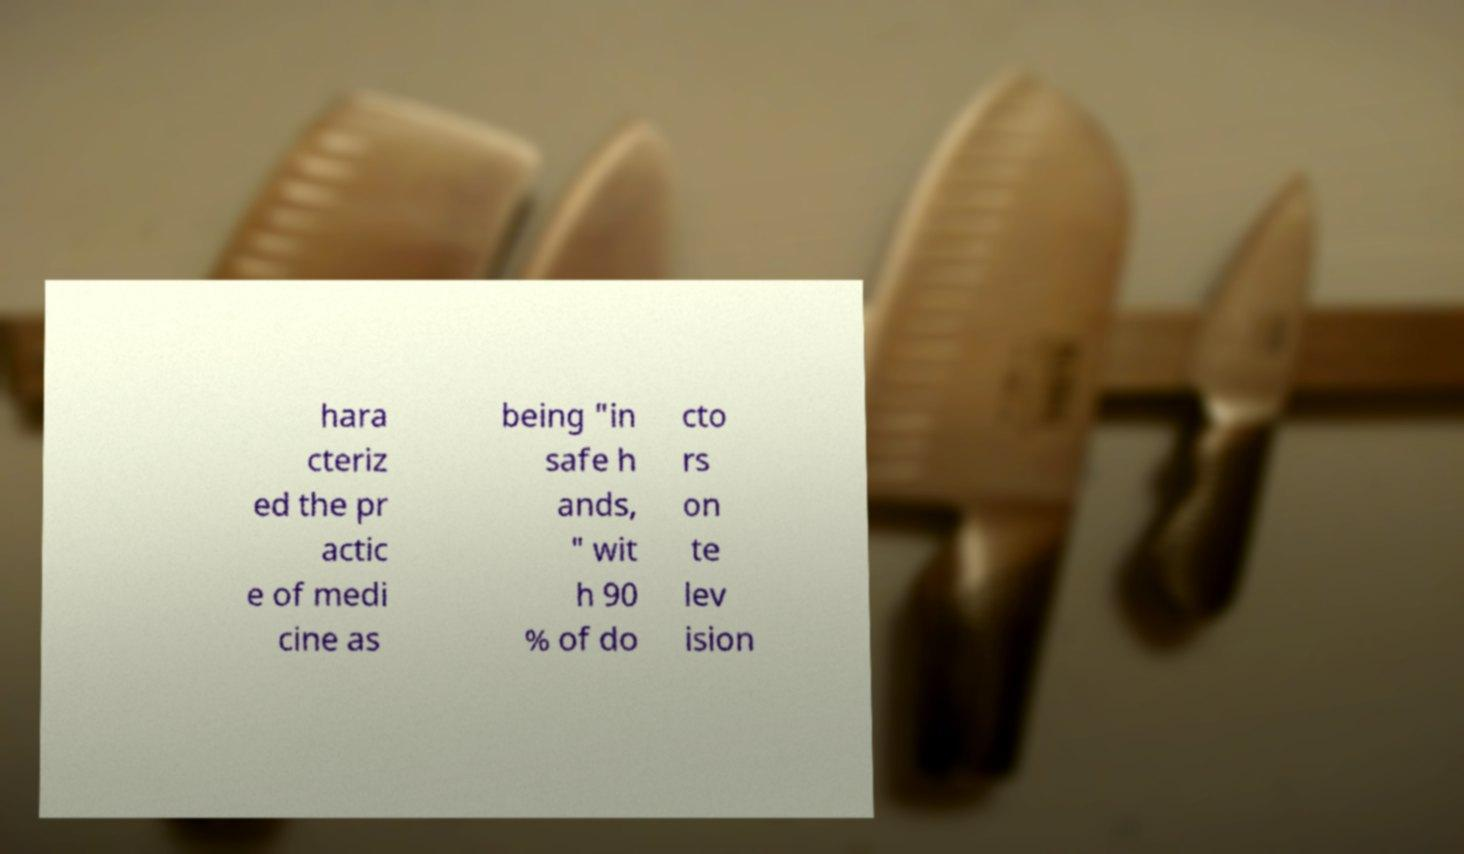I need the written content from this picture converted into text. Can you do that? hara cteriz ed the pr actic e of medi cine as being "in safe h ands, " wit h 90 % of do cto rs on te lev ision 